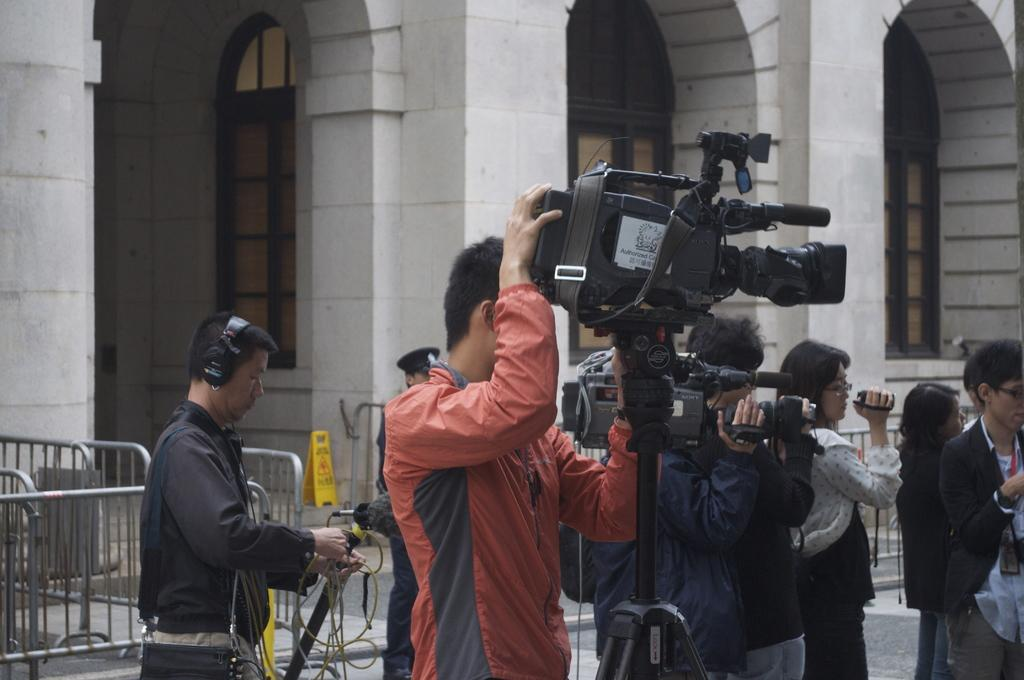Who or what is present in the image? There are people in the image. What are the people holding in their hands? The people are holding cameras. Where are the people standing? The people are standing on the floor. What can be seen in the image besides the people? There are fences and objects in the image. What is visible in the background of the image? There is a building with windows in the background. How does the pear contribute to the people's anger in the image? There is no pear present in the image, and therefore it cannot contribute to any emotions or actions. 